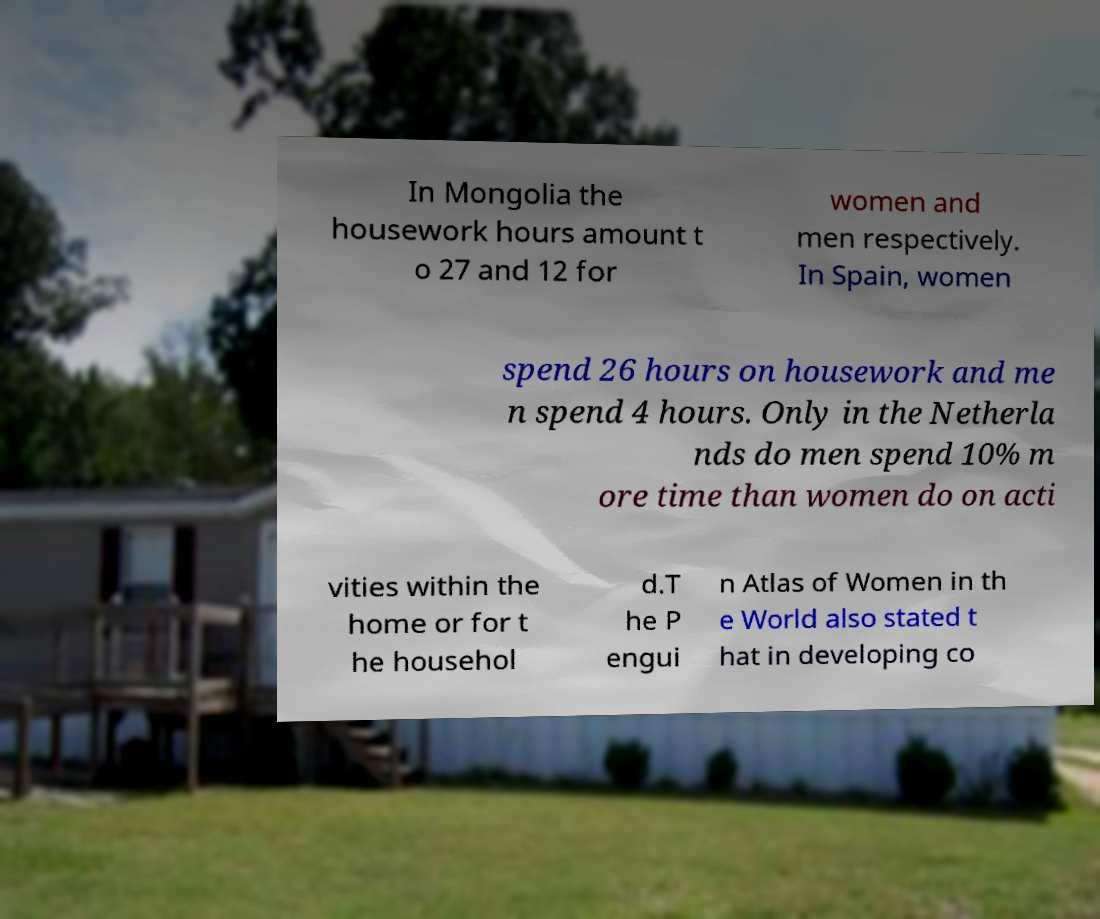Please read and relay the text visible in this image. What does it say? In Mongolia the housework hours amount t o 27 and 12 for women and men respectively. In Spain, women spend 26 hours on housework and me n spend 4 hours. Only in the Netherla nds do men spend 10% m ore time than women do on acti vities within the home or for t he househol d.T he P engui n Atlas of Women in th e World also stated t hat in developing co 